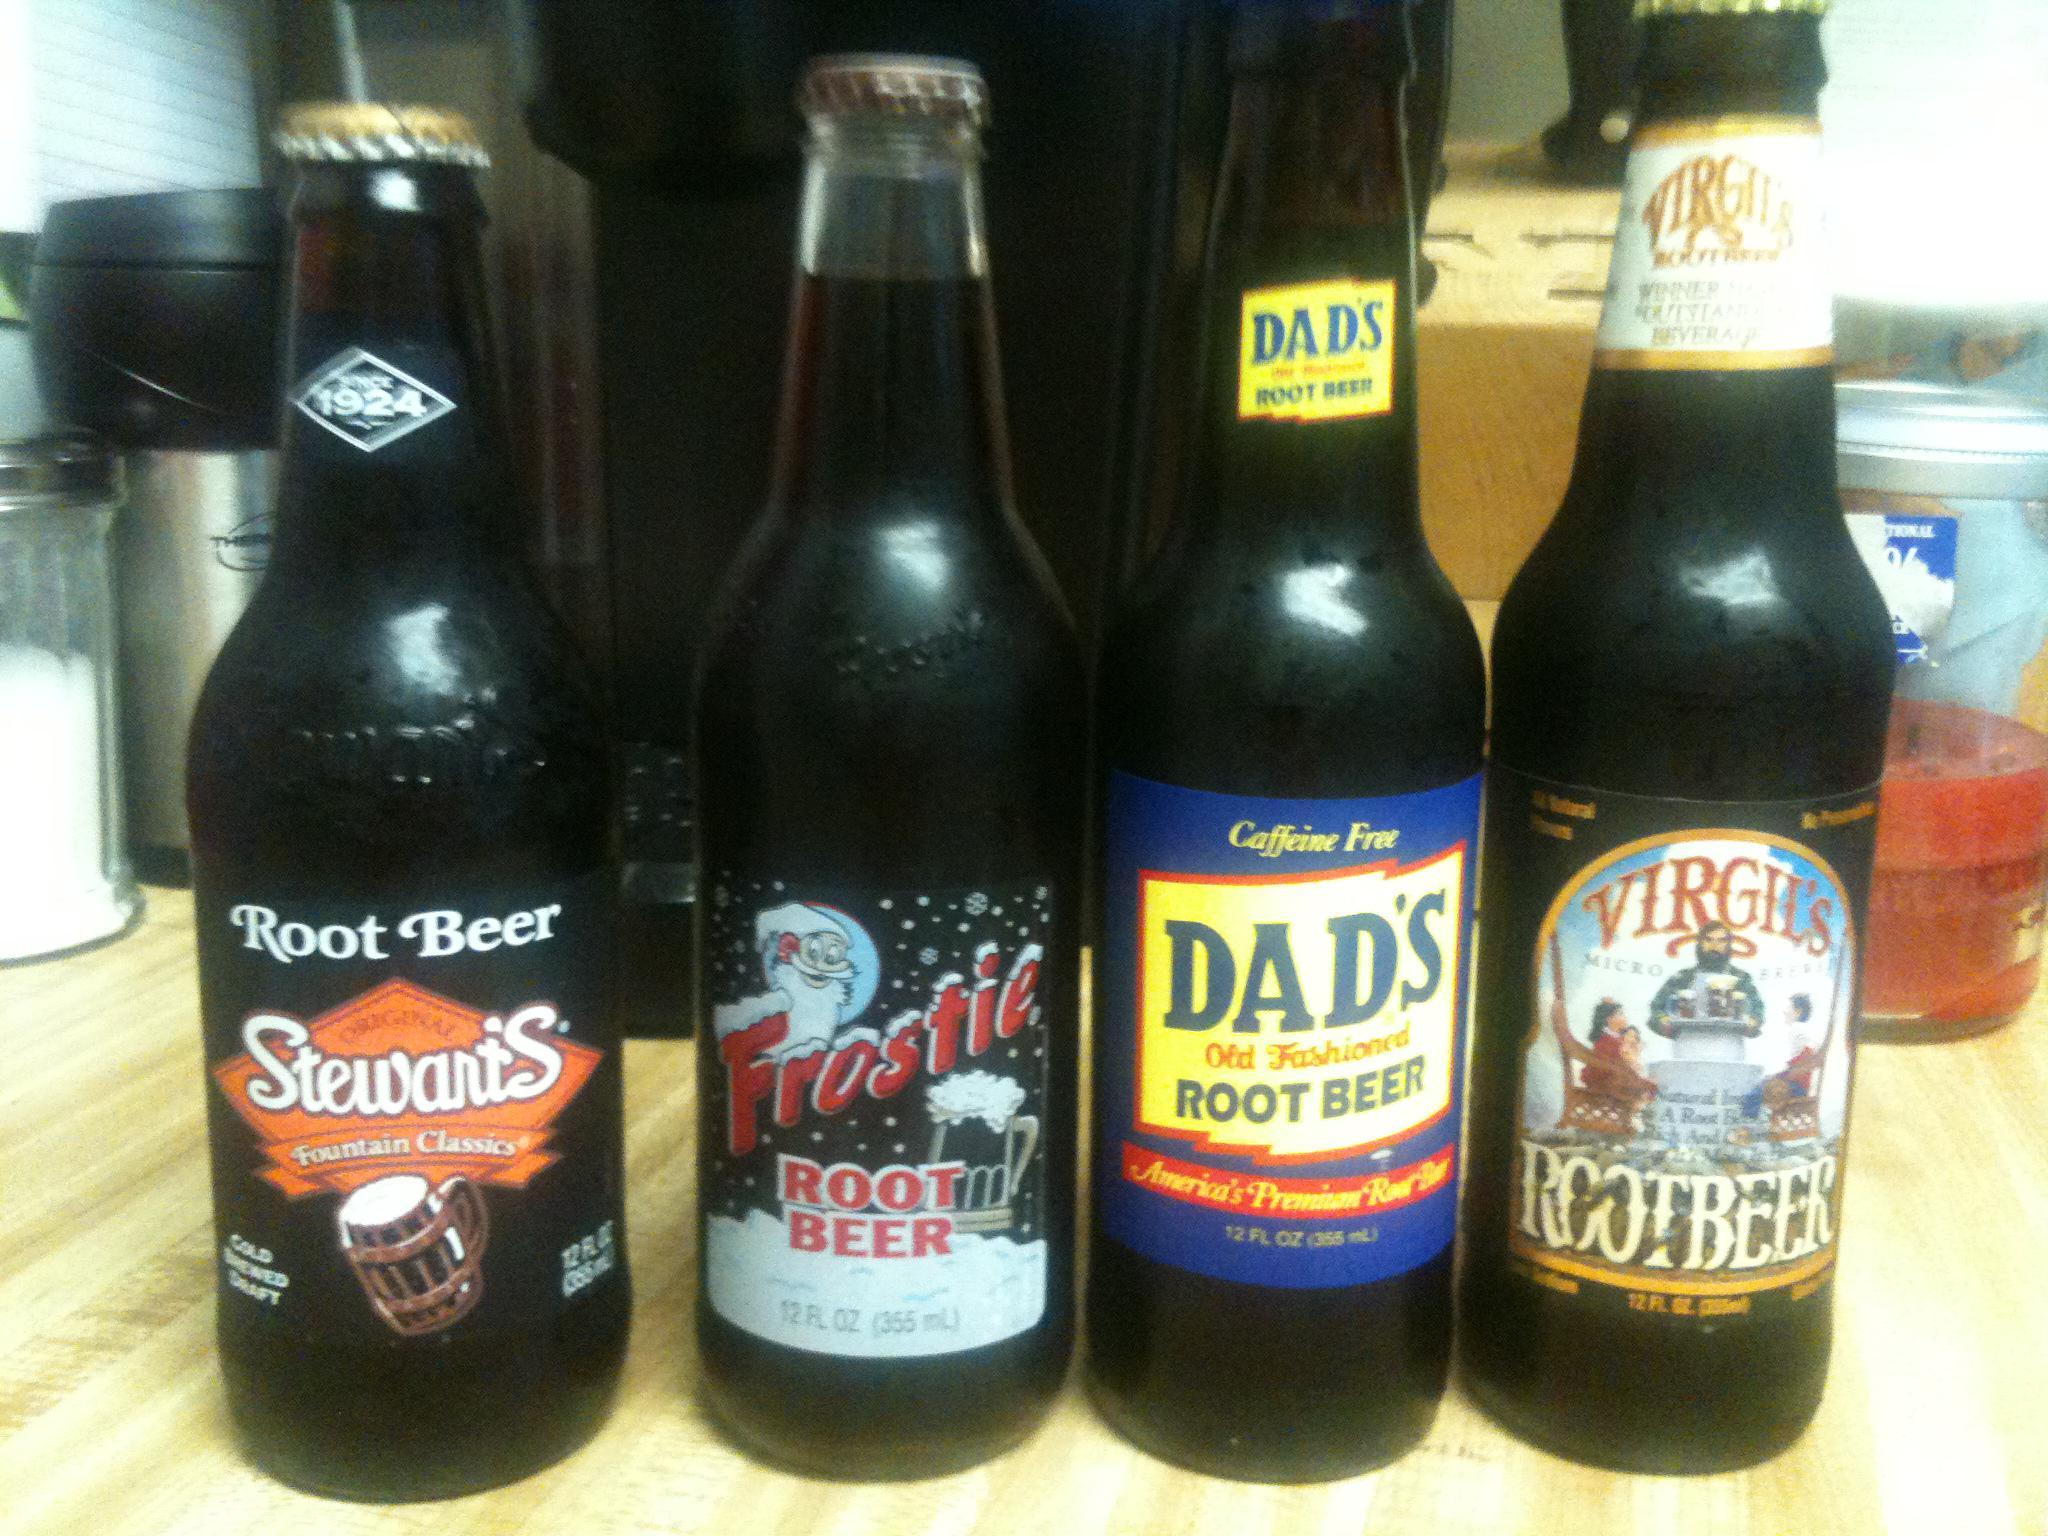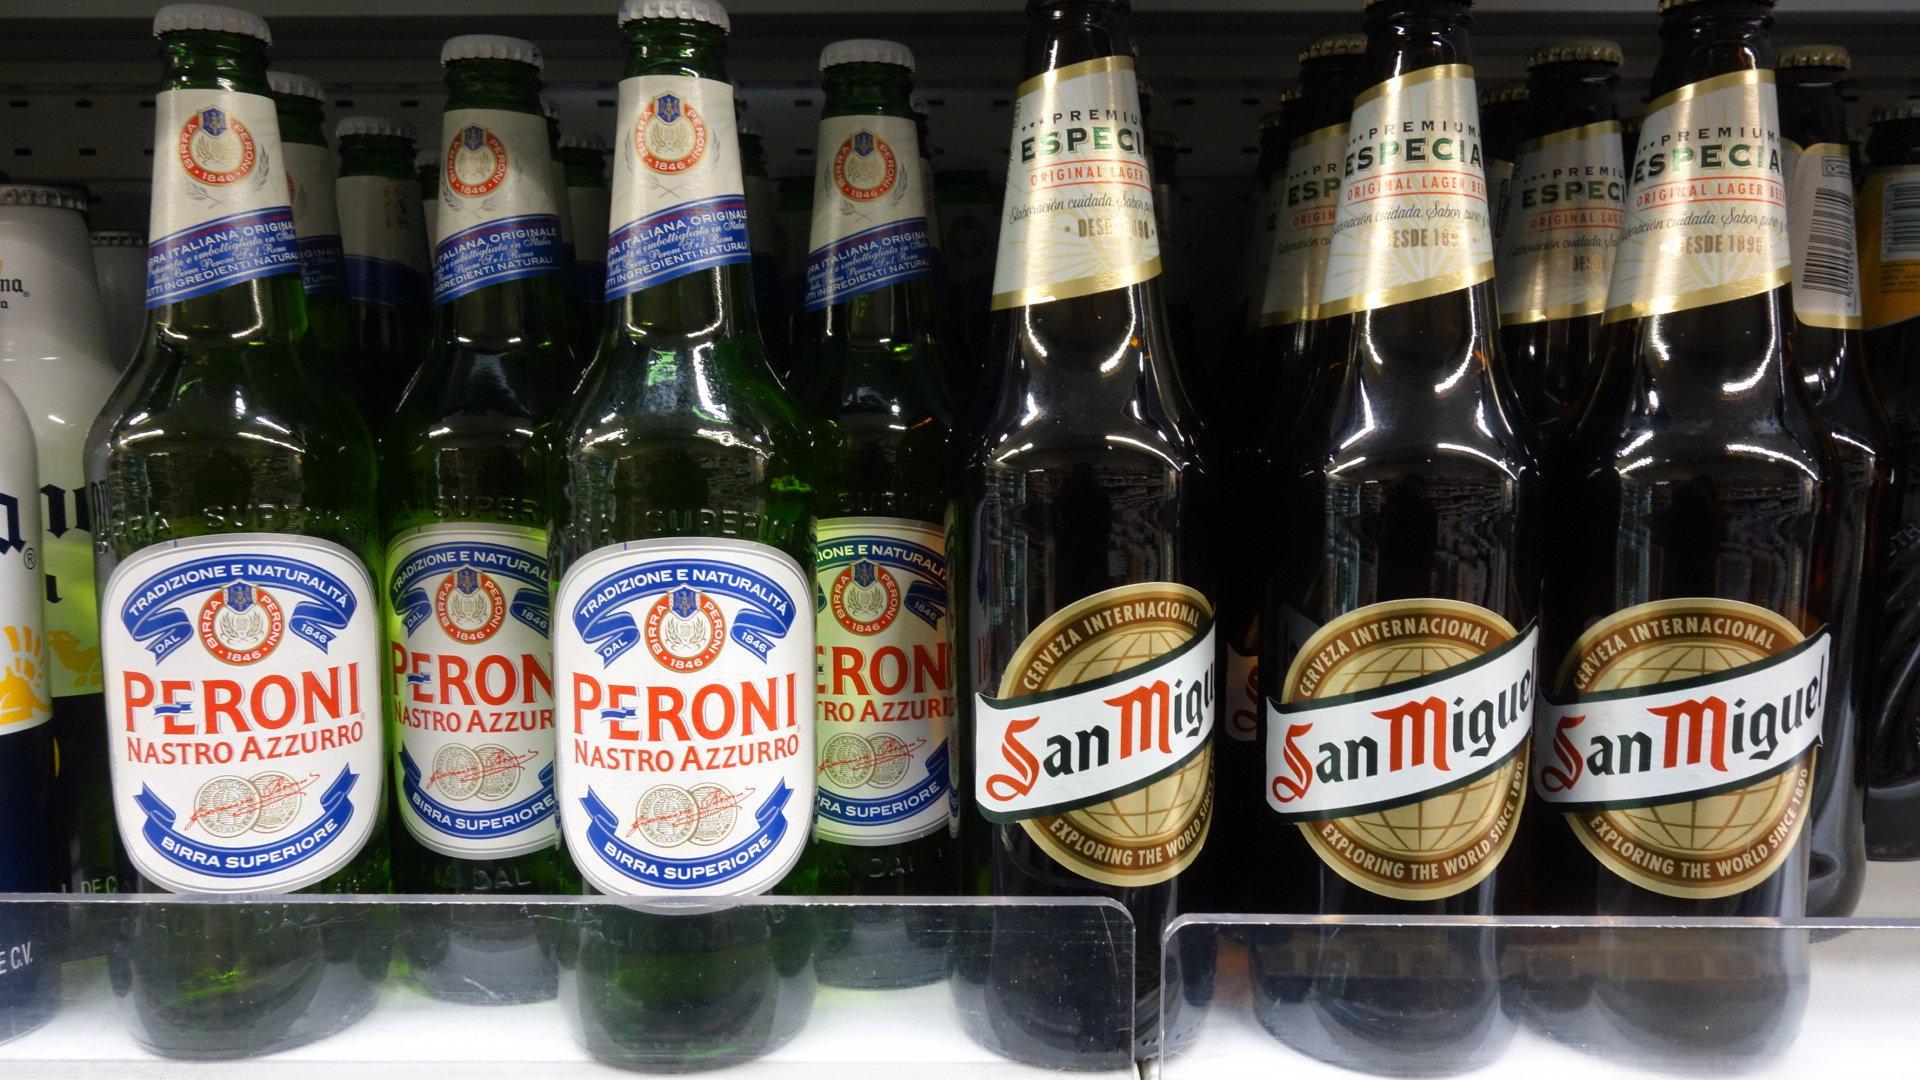The first image is the image on the left, the second image is the image on the right. For the images displayed, is the sentence "There are multiple of the same bottles next to each other." factually correct? Answer yes or no. Yes. The first image is the image on the left, the second image is the image on the right. Examine the images to the left and right. Is the description "The left and right image contains the same number of glass drinking bottles." accurate? Answer yes or no. No. 